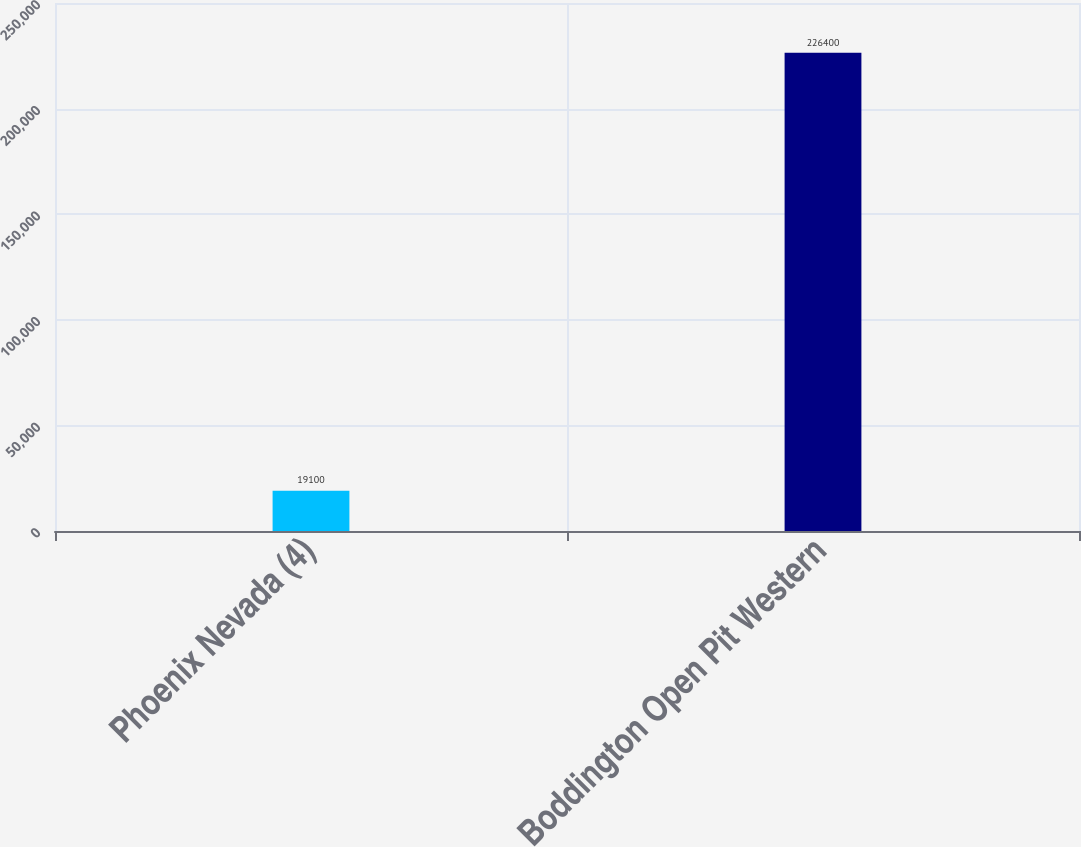Convert chart to OTSL. <chart><loc_0><loc_0><loc_500><loc_500><bar_chart><fcel>Phoenix Nevada (4)<fcel>Boddington Open Pit Western<nl><fcel>19100<fcel>226400<nl></chart> 